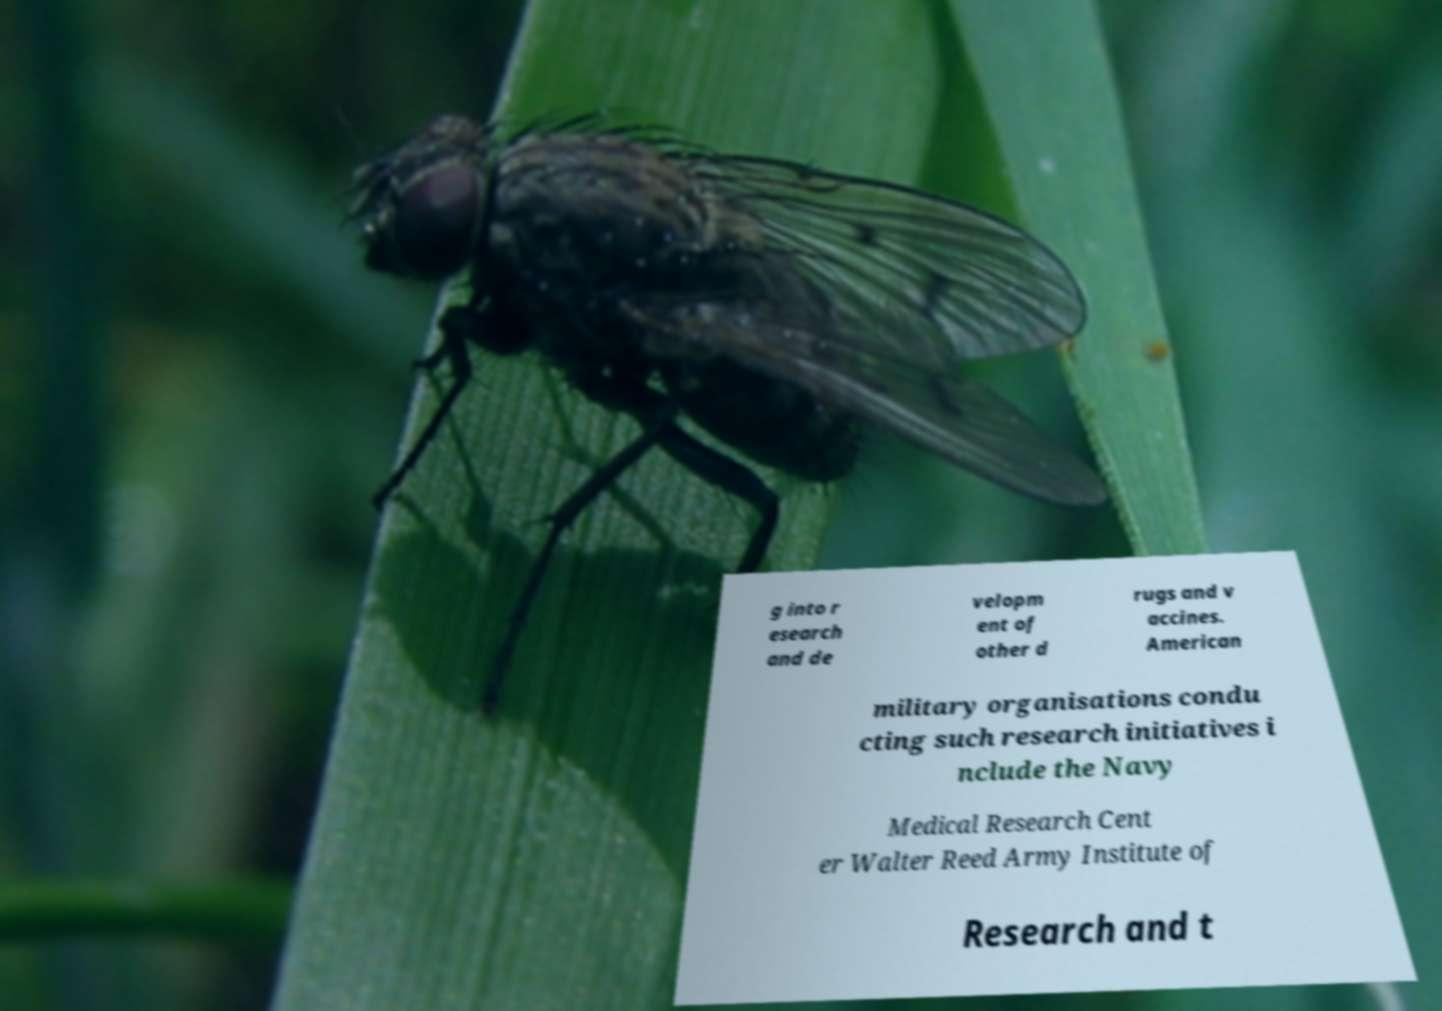Could you assist in decoding the text presented in this image and type it out clearly? g into r esearch and de velopm ent of other d rugs and v accines. American military organisations condu cting such research initiatives i nclude the Navy Medical Research Cent er Walter Reed Army Institute of Research and t 